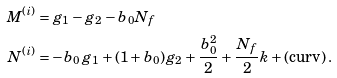<formula> <loc_0><loc_0><loc_500><loc_500>M ^ { ( i ) } & = g _ { 1 } - g _ { 2 } - b _ { 0 } N _ { f } \\ N ^ { ( i ) } & = - b _ { 0 } \, g _ { 1 } + ( 1 + b _ { 0 } ) g _ { 2 } + \frac { b _ { 0 } ^ { 2 } } { 2 } + \frac { N _ { f } } { 2 } k + ( \text {curv} ) \, .</formula> 